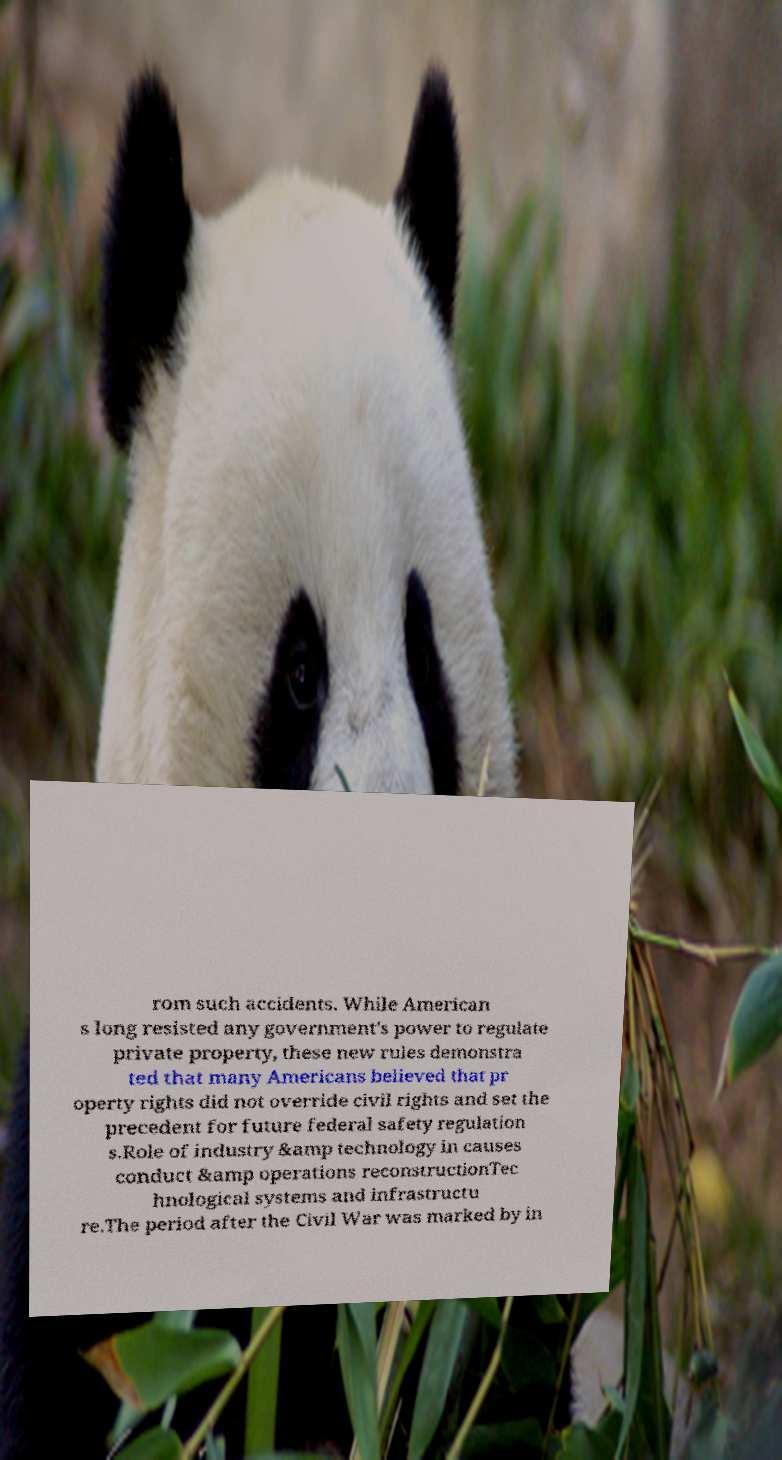Please identify and transcribe the text found in this image. rom such accidents. While American s long resisted any government's power to regulate private property, these new rules demonstra ted that many Americans believed that pr operty rights did not override civil rights and set the precedent for future federal safety regulation s.Role of industry &amp technology in causes conduct &amp operations reconstructionTec hnological systems and infrastructu re.The period after the Civil War was marked by in 